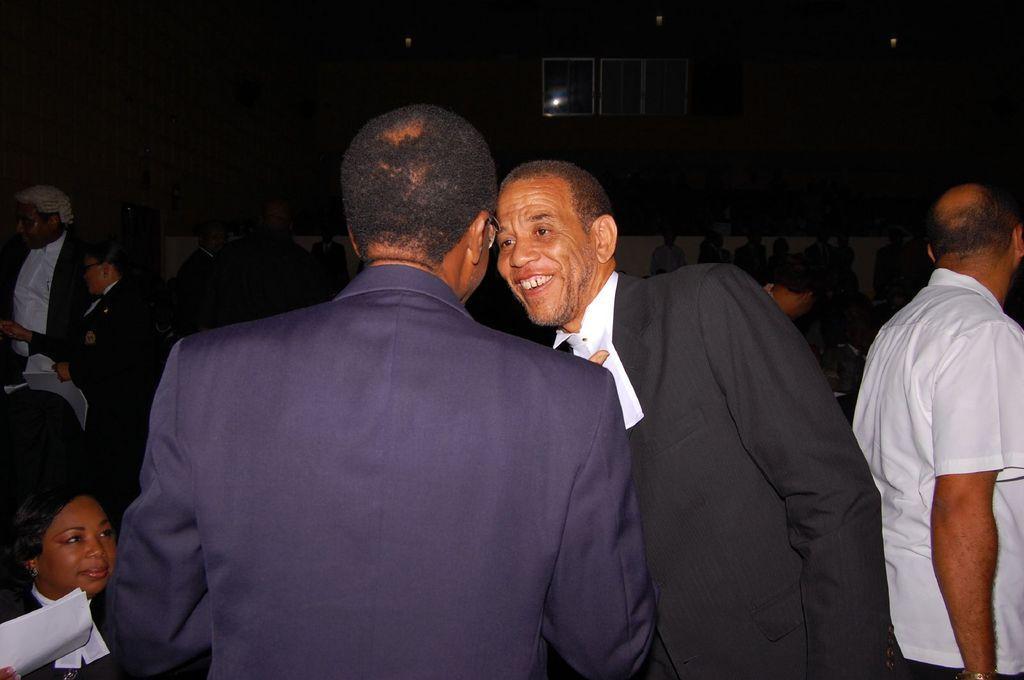Please provide a concise description of this image. In this image we can see some persons. In the background of the image there are persons, wall, windows and other objects. 